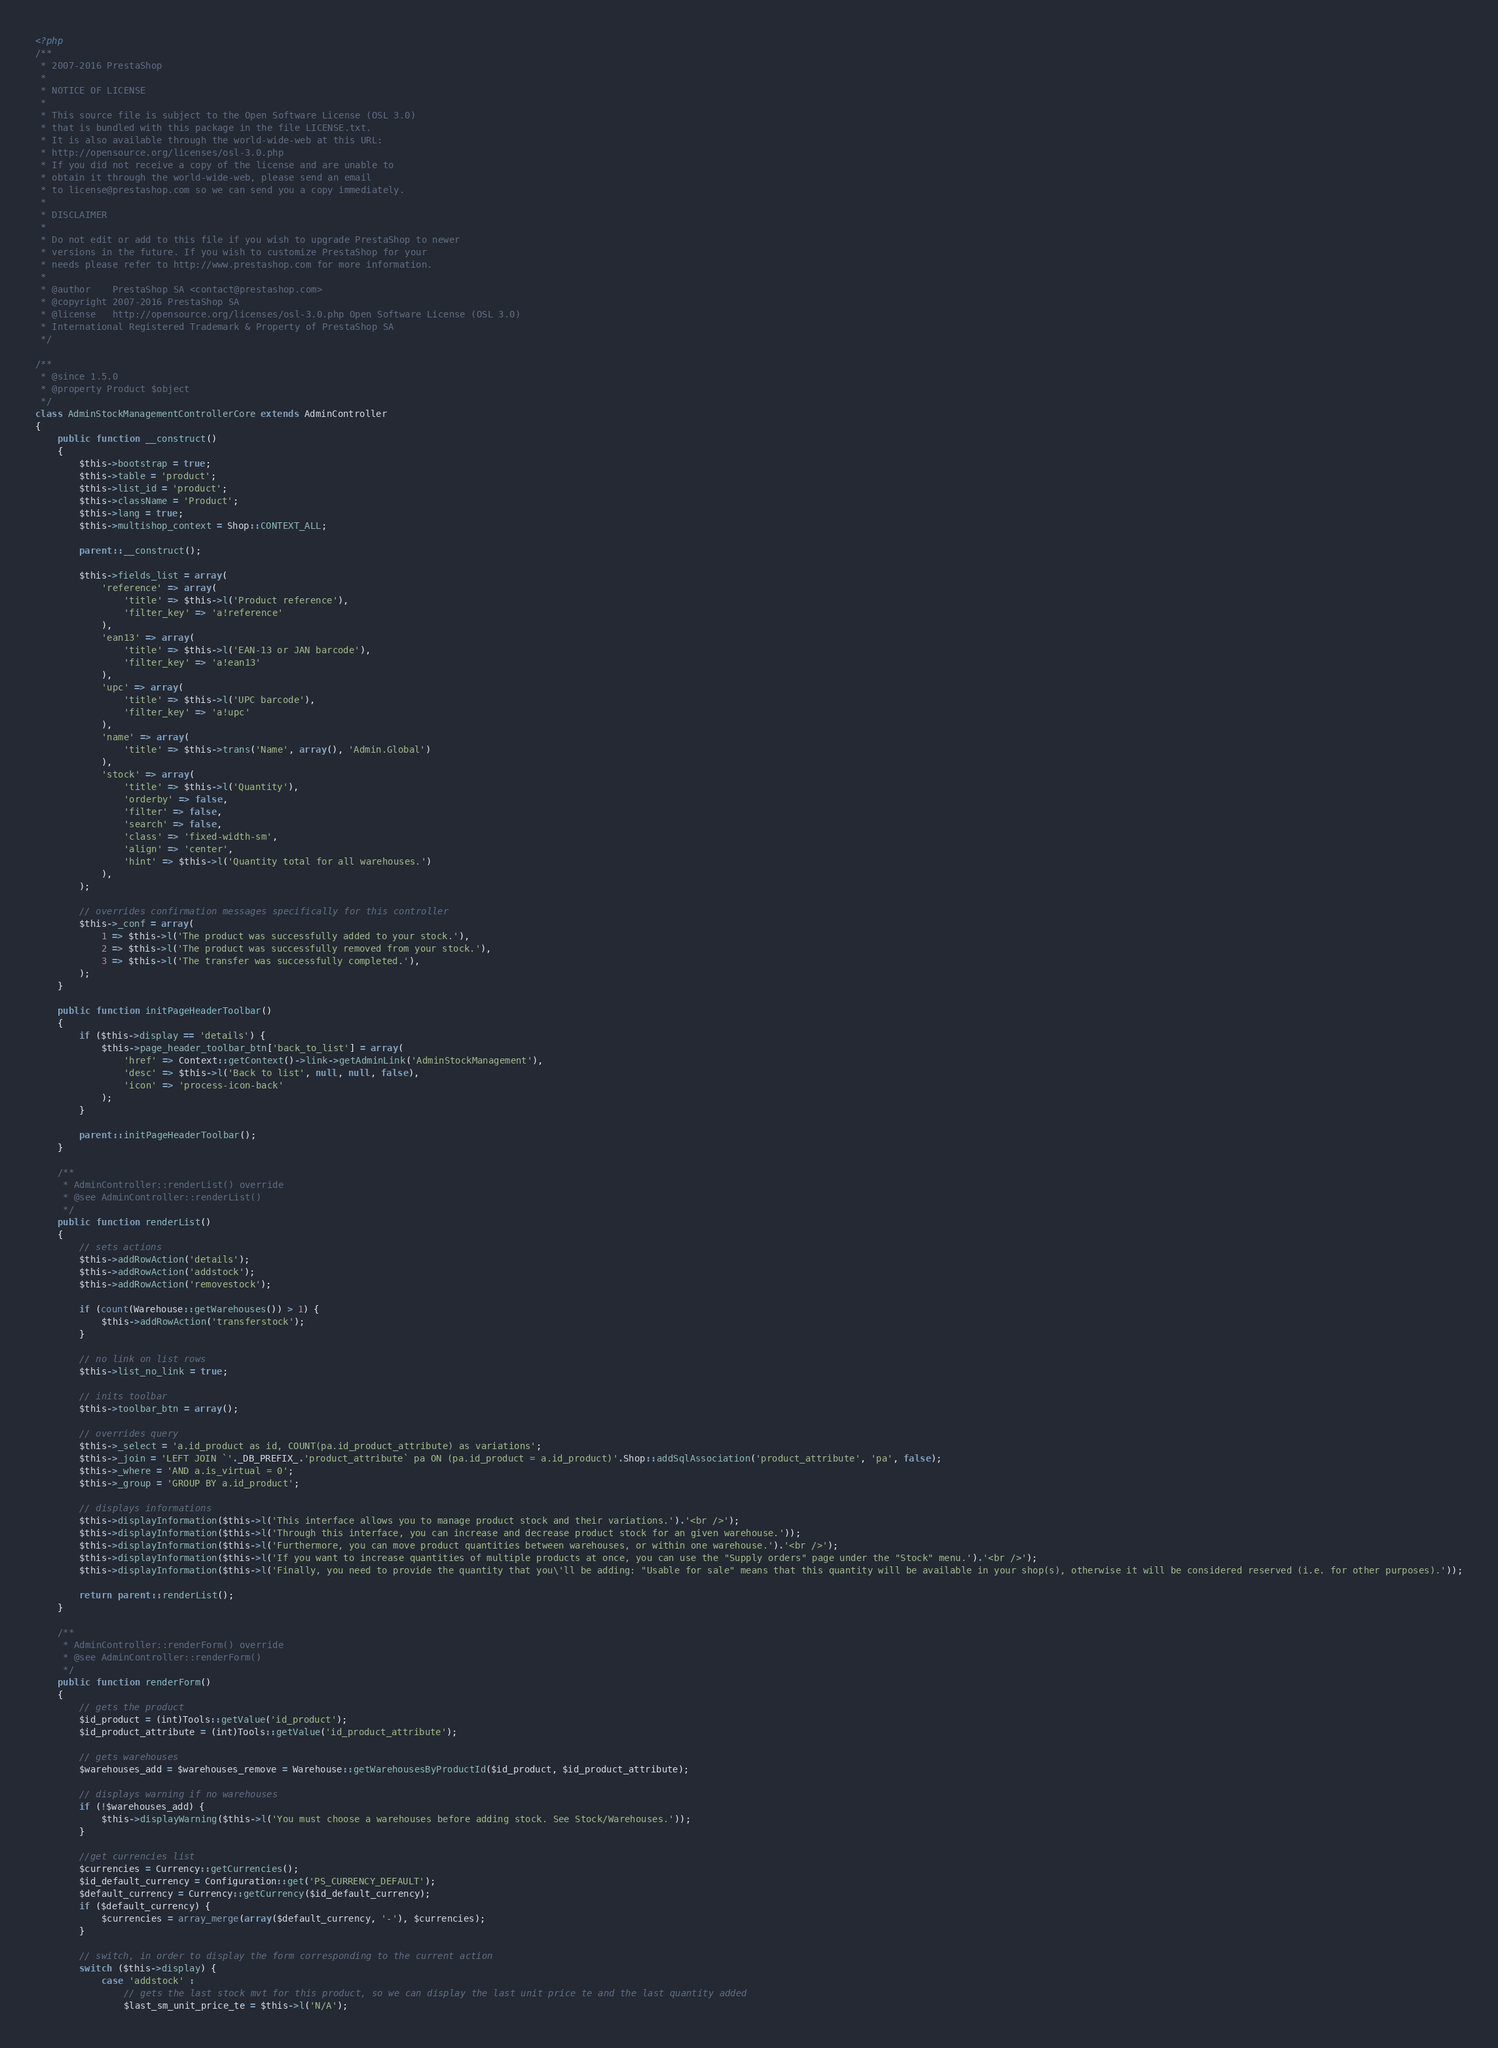<code> <loc_0><loc_0><loc_500><loc_500><_PHP_><?php
/**
 * 2007-2016 PrestaShop
 *
 * NOTICE OF LICENSE
 *
 * This source file is subject to the Open Software License (OSL 3.0)
 * that is bundled with this package in the file LICENSE.txt.
 * It is also available through the world-wide-web at this URL:
 * http://opensource.org/licenses/osl-3.0.php
 * If you did not receive a copy of the license and are unable to
 * obtain it through the world-wide-web, please send an email
 * to license@prestashop.com so we can send you a copy immediately.
 *
 * DISCLAIMER
 *
 * Do not edit or add to this file if you wish to upgrade PrestaShop to newer
 * versions in the future. If you wish to customize PrestaShop for your
 * needs please refer to http://www.prestashop.com for more information.
 *
 * @author    PrestaShop SA <contact@prestashop.com>
 * @copyright 2007-2016 PrestaShop SA
 * @license   http://opensource.org/licenses/osl-3.0.php Open Software License (OSL 3.0)
 * International Registered Trademark & Property of PrestaShop SA
 */

/**
 * @since 1.5.0
 * @property Product $object
 */
class AdminStockManagementControllerCore extends AdminController
{
    public function __construct()
    {
        $this->bootstrap = true;
        $this->table = 'product';
        $this->list_id = 'product';
        $this->className = 'Product';
        $this->lang = true;
        $this->multishop_context = Shop::CONTEXT_ALL;

        parent::__construct();

        $this->fields_list = array(
            'reference' => array(
                'title' => $this->l('Product reference'),
                'filter_key' => 'a!reference'
            ),
            'ean13' => array(
                'title' => $this->l('EAN-13 or JAN barcode'),
                'filter_key' => 'a!ean13'
            ),
            'upc' => array(
                'title' => $this->l('UPC barcode'),
                'filter_key' => 'a!upc'
            ),
            'name' => array(
                'title' => $this->trans('Name', array(), 'Admin.Global')
            ),
            'stock' => array(
                'title' => $this->l('Quantity'),
                'orderby' => false,
                'filter' => false,
                'search' => false,
                'class' => 'fixed-width-sm',
                'align' => 'center',
                'hint' => $this->l('Quantity total for all warehouses.')
            ),
        );

        // overrides confirmation messages specifically for this controller
        $this->_conf = array(
            1 => $this->l('The product was successfully added to your stock.'),
            2 => $this->l('The product was successfully removed from your stock.'),
            3 => $this->l('The transfer was successfully completed.'),
        );
    }

    public function initPageHeaderToolbar()
    {
        if ($this->display == 'details') {
            $this->page_header_toolbar_btn['back_to_list'] = array(
                'href' => Context::getContext()->link->getAdminLink('AdminStockManagement'),
                'desc' => $this->l('Back to list', null, null, false),
                'icon' => 'process-icon-back'
            );
        }

        parent::initPageHeaderToolbar();
    }

    /**
     * AdminController::renderList() override
     * @see AdminController::renderList()
     */
    public function renderList()
    {
        // sets actions
        $this->addRowAction('details');
        $this->addRowAction('addstock');
        $this->addRowAction('removestock');

        if (count(Warehouse::getWarehouses()) > 1) {
            $this->addRowAction('transferstock');
        }

        // no link on list rows
        $this->list_no_link = true;

        // inits toolbar
        $this->toolbar_btn = array();

        // overrides query
        $this->_select = 'a.id_product as id, COUNT(pa.id_product_attribute) as variations';
        $this->_join = 'LEFT JOIN `'._DB_PREFIX_.'product_attribute` pa ON (pa.id_product = a.id_product)'.Shop::addSqlAssociation('product_attribute', 'pa', false);
        $this->_where = 'AND a.is_virtual = 0';
        $this->_group = 'GROUP BY a.id_product';

        // displays informations
        $this->displayInformation($this->l('This interface allows you to manage product stock and their variations.').'<br />');
        $this->displayInformation($this->l('Through this interface, you can increase and decrease product stock for an given warehouse.'));
        $this->displayInformation($this->l('Furthermore, you can move product quantities between warehouses, or within one warehouse.').'<br />');
        $this->displayInformation($this->l('If you want to increase quantities of multiple products at once, you can use the "Supply orders" page under the "Stock" menu.').'<br />');
        $this->displayInformation($this->l('Finally, you need to provide the quantity that you\'ll be adding: "Usable for sale" means that this quantity will be available in your shop(s), otherwise it will be considered reserved (i.e. for other purposes).'));

        return parent::renderList();
    }

    /**
     * AdminController::renderForm() override
     * @see AdminController::renderForm()
     */
    public function renderForm()
    {
        // gets the product
        $id_product = (int)Tools::getValue('id_product');
        $id_product_attribute = (int)Tools::getValue('id_product_attribute');

        // gets warehouses
        $warehouses_add = $warehouses_remove = Warehouse::getWarehousesByProductId($id_product, $id_product_attribute);

        // displays warning if no warehouses
        if (!$warehouses_add) {
            $this->displayWarning($this->l('You must choose a warehouses before adding stock. See Stock/Warehouses.'));
        }

        //get currencies list
        $currencies = Currency::getCurrencies();
        $id_default_currency = Configuration::get('PS_CURRENCY_DEFAULT');
        $default_currency = Currency::getCurrency($id_default_currency);
        if ($default_currency) {
            $currencies = array_merge(array($default_currency, '-'), $currencies);
        }

        // switch, in order to display the form corresponding to the current action
        switch ($this->display) {
            case 'addstock' :
                // gets the last stock mvt for this product, so we can display the last unit price te and the last quantity added
                $last_sm_unit_price_te = $this->l('N/A');</code> 